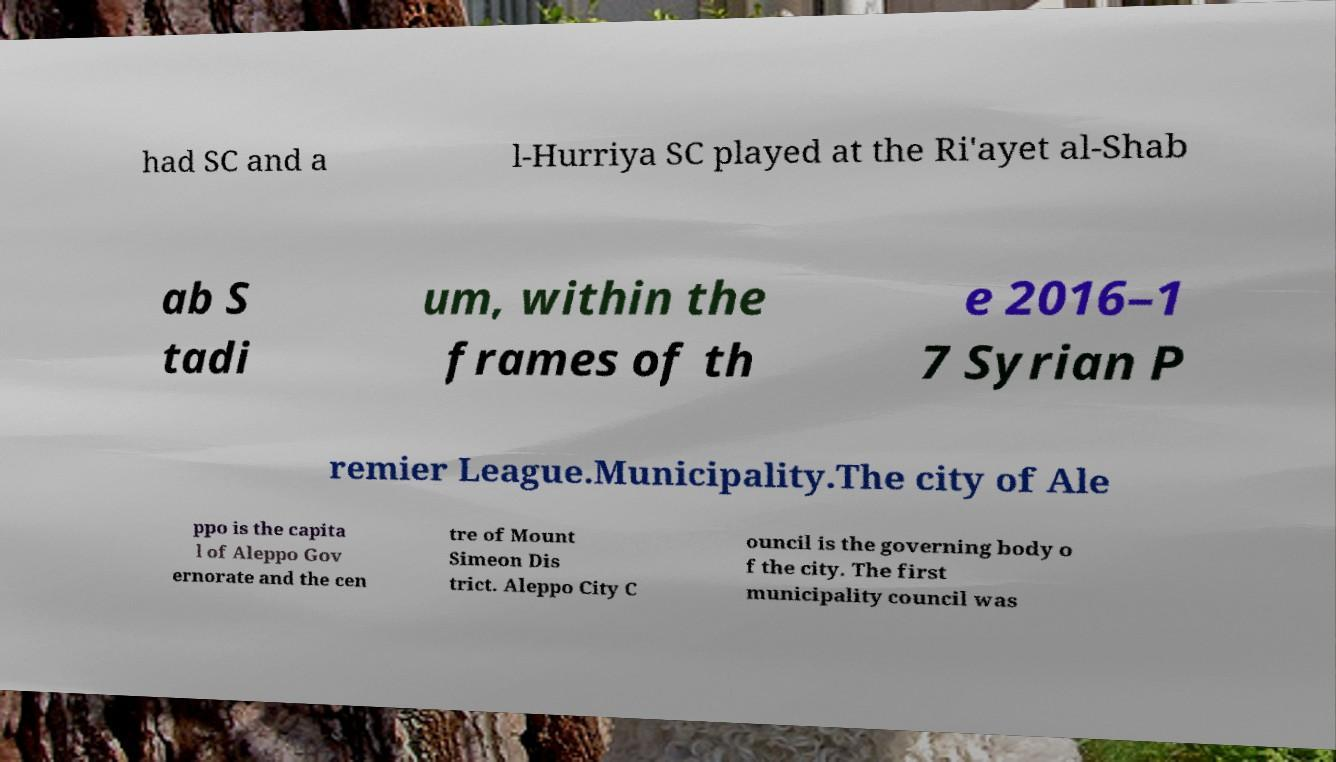Could you extract and type out the text from this image? had SC and a l-Hurriya SC played at the Ri'ayet al-Shab ab S tadi um, within the frames of th e 2016–1 7 Syrian P remier League.Municipality.The city of Ale ppo is the capita l of Aleppo Gov ernorate and the cen tre of Mount Simeon Dis trict. Aleppo City C ouncil is the governing body o f the city. The first municipality council was 